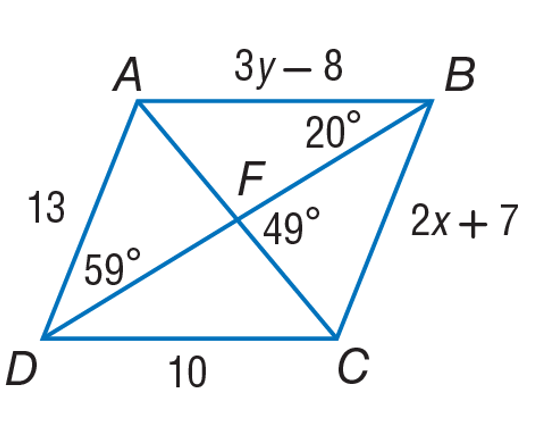Answer the mathemtical geometry problem and directly provide the correct option letter.
Question: Use parallelogram A B C D to find y.
Choices: A: 3 B: 6 C: 10 D: 13 B 